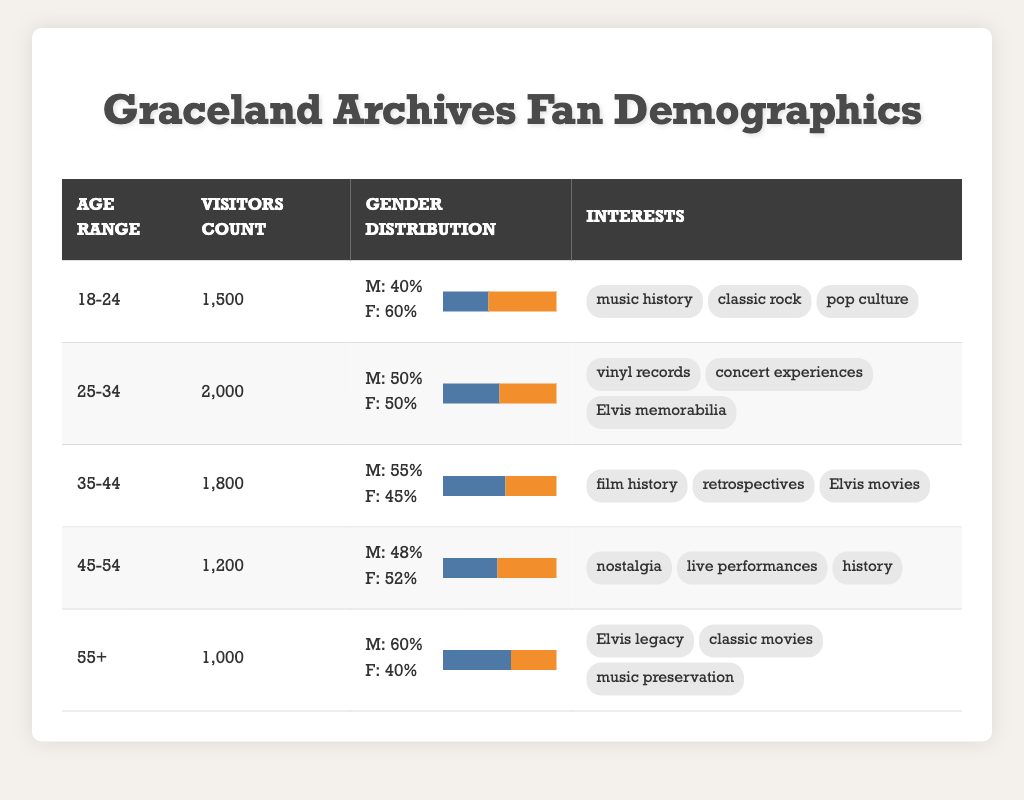What is the total number of visitors from the age range 25-34? The visitors count for the age range 25-34 is explicitly listed in the table. It shows 2000 visitors within this age range.
Answer: 2000 Which age range has the highest percentage of male visitors? By comparing the gender distribution percentages from the table, the 55+ age range has the highest male percentage at 60%.
Answer: 55+ What is the average number of visitors across all age ranges? To find the average, sum the visitors count for all age ranges (1500 + 2000 + 1800 + 1200 + 1000 = 8300) and divide by the number of age ranges, which is 5 (8300 / 5 = 1660).
Answer: 1660 Do visitors aged 18-24 have more interest in "classic rock" or "music preservation"? The interests of visitors aged 18-24 are "music history," "classic rock," and "pop culture," while the interests for visitors aged 55+ include "Elvis legacy," "classic movies," and "music preservation." Thus, the 18-24 age group has no interest in "music preservation."
Answer: No What percentage of visitors in the age range 45-54 identify as female? The gender distribution for the age range 45-54 shows 52% female.
Answer: 52% Among all age ranges, which group has the least number of visitors? By examining the visitors count in the table, the least number of visitors is for the age range 55+, with a total of 1000 visitors.
Answer: 55+ Is it true that the majority of visitors in the 35-44 age range are female? The gender distribution for the 35-44 age range shows 55% male and 45% female. Since the male percentage is higher, it is not true that the majority are female.
Answer: No How many more visitors are there in the 25-34 age range than in the 55+ age range? The 25-34 age range has 2000 visitors while the 55+ age range has 1000 visitors. The difference is calculated by subtracting 1000 from 2000, which results in 1000 more visitors in the 25-34 age range.
Answer: 1000 What are the common interests shared by visitors in the age range 45-54? The interests for the age range 45-54 listed in the table are "nostalgia," "live performances," and "history." These interests collectively reflect a focus on the past experiences and events.
Answer: Nostalgia, live performances, history 